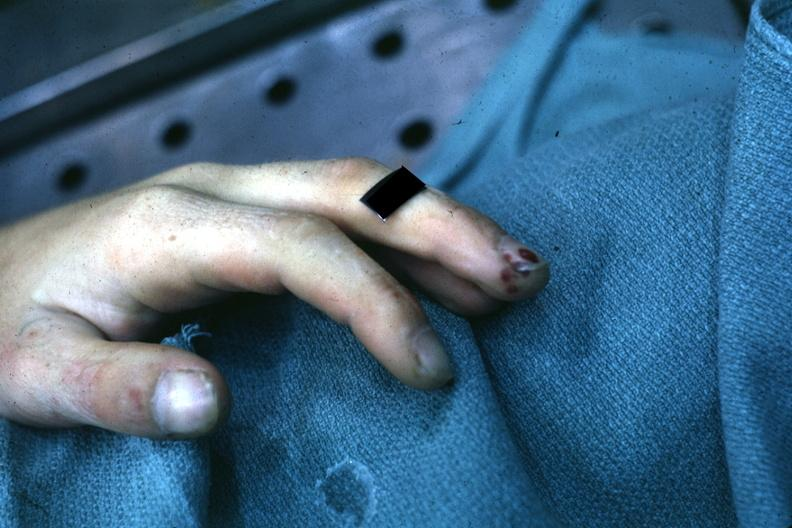re extremities present?
Answer the question using a single word or phrase. Yes 